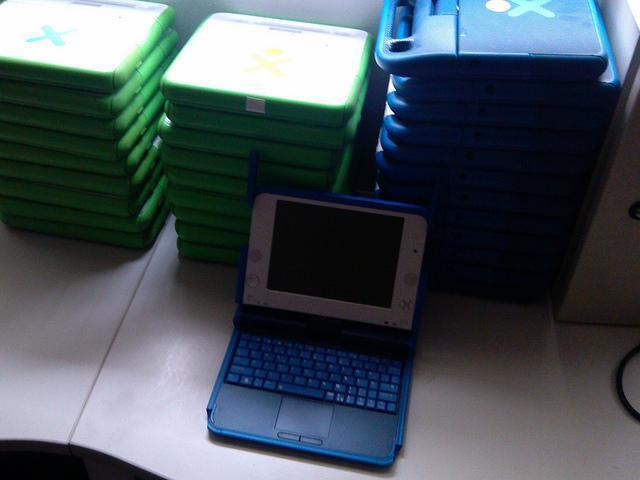How many laptops are visible?
Give a very brief answer. 14. 